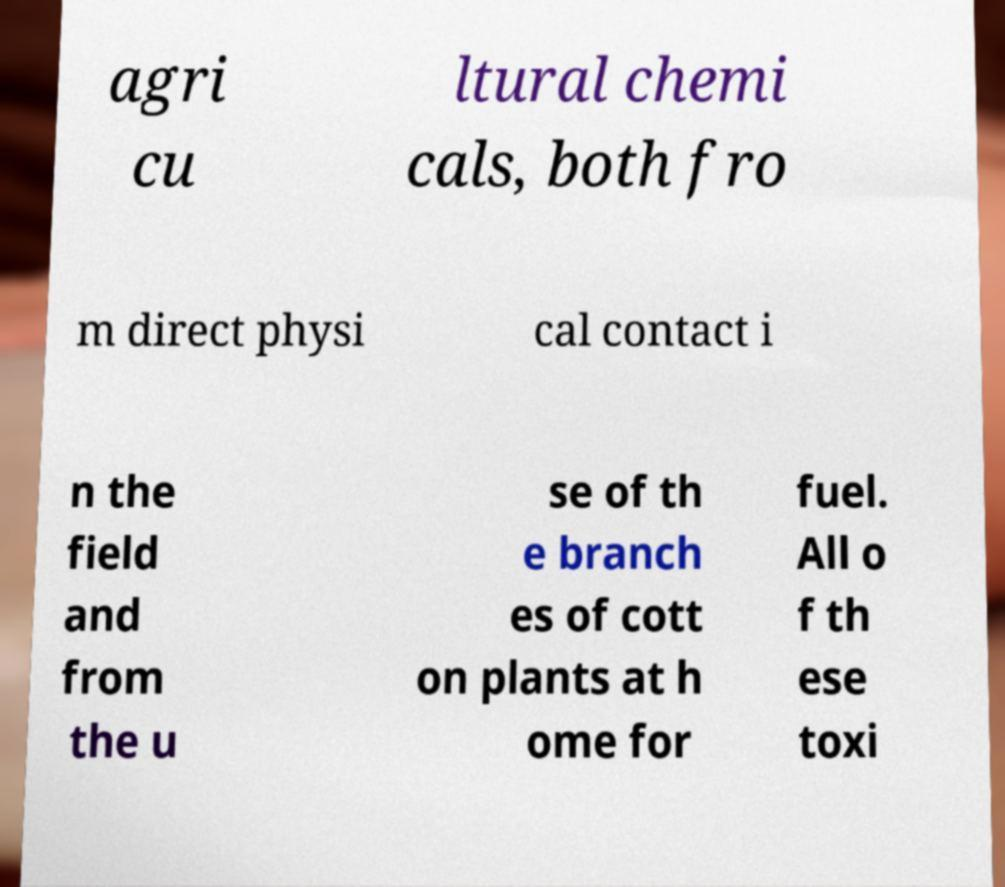Can you accurately transcribe the text from the provided image for me? agri cu ltural chemi cals, both fro m direct physi cal contact i n the field and from the u se of th e branch es of cott on plants at h ome for fuel. All o f th ese toxi 